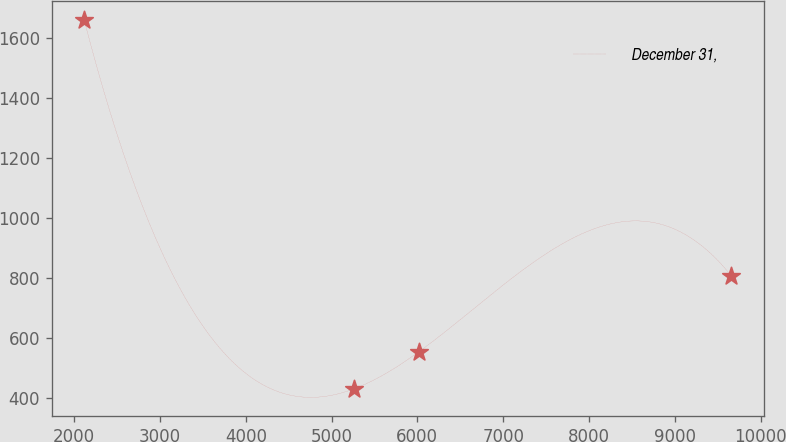Convert chart. <chart><loc_0><loc_0><loc_500><loc_500><line_chart><ecel><fcel>December 31,<nl><fcel>2115.68<fcel>1659.88<nl><fcel>5260.01<fcel>429.79<nl><fcel>6014.4<fcel>552.8<nl><fcel>9659.57<fcel>806.21<nl></chart> 